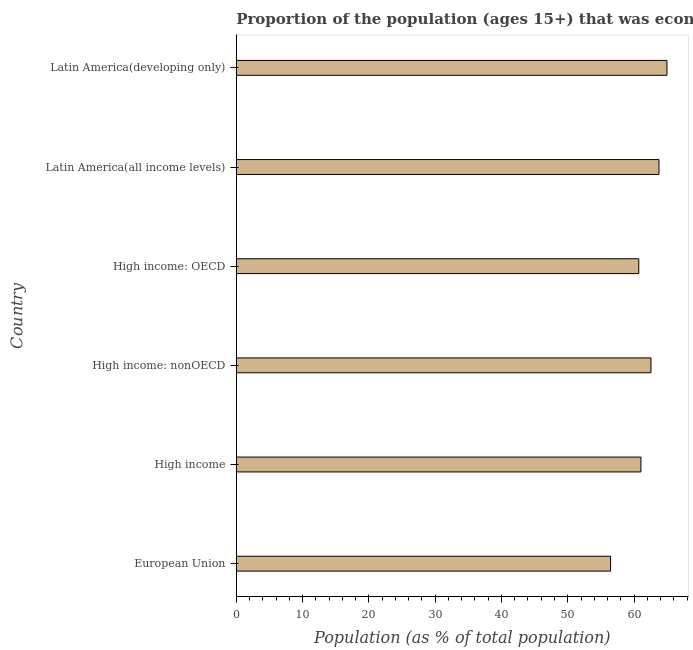What is the title of the graph?
Keep it short and to the point. Proportion of the population (ages 15+) that was economically active in the year 2003. What is the label or title of the X-axis?
Offer a very short reply. Population (as % of total population). What is the percentage of economically active population in High income: nonOECD?
Offer a very short reply. 62.55. Across all countries, what is the maximum percentage of economically active population?
Provide a short and direct response. 64.96. Across all countries, what is the minimum percentage of economically active population?
Give a very brief answer. 56.46. In which country was the percentage of economically active population maximum?
Keep it short and to the point. Latin America(developing only). In which country was the percentage of economically active population minimum?
Provide a succinct answer. European Union. What is the sum of the percentage of economically active population?
Keep it short and to the point. 369.5. What is the difference between the percentage of economically active population in European Union and Latin America(developing only)?
Keep it short and to the point. -8.5. What is the average percentage of economically active population per country?
Offer a very short reply. 61.58. What is the median percentage of economically active population?
Ensure brevity in your answer.  61.8. In how many countries, is the percentage of economically active population greater than 4 %?
Your answer should be compact. 6. What is the ratio of the percentage of economically active population in High income to that in Latin America(developing only)?
Make the answer very short. 0.94. Is the percentage of economically active population in High income less than that in Latin America(all income levels)?
Give a very brief answer. Yes. Is the difference between the percentage of economically active population in European Union and High income: nonOECD greater than the difference between any two countries?
Provide a succinct answer. No. What is the difference between the highest and the second highest percentage of economically active population?
Offer a very short reply. 1.2. What is the difference between the highest and the lowest percentage of economically active population?
Your response must be concise. 8.5. In how many countries, is the percentage of economically active population greater than the average percentage of economically active population taken over all countries?
Offer a very short reply. 3. Are the values on the major ticks of X-axis written in scientific E-notation?
Your answer should be very brief. No. What is the Population (as % of total population) in European Union?
Offer a very short reply. 56.46. What is the Population (as % of total population) in High income?
Your response must be concise. 61.04. What is the Population (as % of total population) in High income: nonOECD?
Provide a succinct answer. 62.55. What is the Population (as % of total population) in High income: OECD?
Give a very brief answer. 60.71. What is the Population (as % of total population) in Latin America(all income levels)?
Your response must be concise. 63.76. What is the Population (as % of total population) in Latin America(developing only)?
Ensure brevity in your answer.  64.96. What is the difference between the Population (as % of total population) in European Union and High income?
Provide a succinct answer. -4.58. What is the difference between the Population (as % of total population) in European Union and High income: nonOECD?
Provide a short and direct response. -6.09. What is the difference between the Population (as % of total population) in European Union and High income: OECD?
Provide a short and direct response. -4.25. What is the difference between the Population (as % of total population) in European Union and Latin America(all income levels)?
Your answer should be very brief. -7.3. What is the difference between the Population (as % of total population) in European Union and Latin America(developing only)?
Ensure brevity in your answer.  -8.5. What is the difference between the Population (as % of total population) in High income and High income: nonOECD?
Offer a terse response. -1.51. What is the difference between the Population (as % of total population) in High income and High income: OECD?
Provide a succinct answer. 0.33. What is the difference between the Population (as % of total population) in High income and Latin America(all income levels)?
Make the answer very short. -2.72. What is the difference between the Population (as % of total population) in High income and Latin America(developing only)?
Ensure brevity in your answer.  -3.92. What is the difference between the Population (as % of total population) in High income: nonOECD and High income: OECD?
Make the answer very short. 1.84. What is the difference between the Population (as % of total population) in High income: nonOECD and Latin America(all income levels)?
Offer a very short reply. -1.21. What is the difference between the Population (as % of total population) in High income: nonOECD and Latin America(developing only)?
Provide a succinct answer. -2.41. What is the difference between the Population (as % of total population) in High income: OECD and Latin America(all income levels)?
Ensure brevity in your answer.  -3.05. What is the difference between the Population (as % of total population) in High income: OECD and Latin America(developing only)?
Offer a terse response. -4.25. What is the difference between the Population (as % of total population) in Latin America(all income levels) and Latin America(developing only)?
Provide a succinct answer. -1.2. What is the ratio of the Population (as % of total population) in European Union to that in High income?
Provide a short and direct response. 0.93. What is the ratio of the Population (as % of total population) in European Union to that in High income: nonOECD?
Make the answer very short. 0.9. What is the ratio of the Population (as % of total population) in European Union to that in Latin America(all income levels)?
Give a very brief answer. 0.89. What is the ratio of the Population (as % of total population) in European Union to that in Latin America(developing only)?
Your answer should be very brief. 0.87. What is the ratio of the Population (as % of total population) in High income to that in High income: nonOECD?
Offer a very short reply. 0.98. What is the ratio of the Population (as % of total population) in High income: nonOECD to that in High income: OECD?
Offer a very short reply. 1.03. What is the ratio of the Population (as % of total population) in High income: nonOECD to that in Latin America(developing only)?
Your answer should be very brief. 0.96. What is the ratio of the Population (as % of total population) in High income: OECD to that in Latin America(developing only)?
Provide a short and direct response. 0.94. What is the ratio of the Population (as % of total population) in Latin America(all income levels) to that in Latin America(developing only)?
Your answer should be very brief. 0.98. 